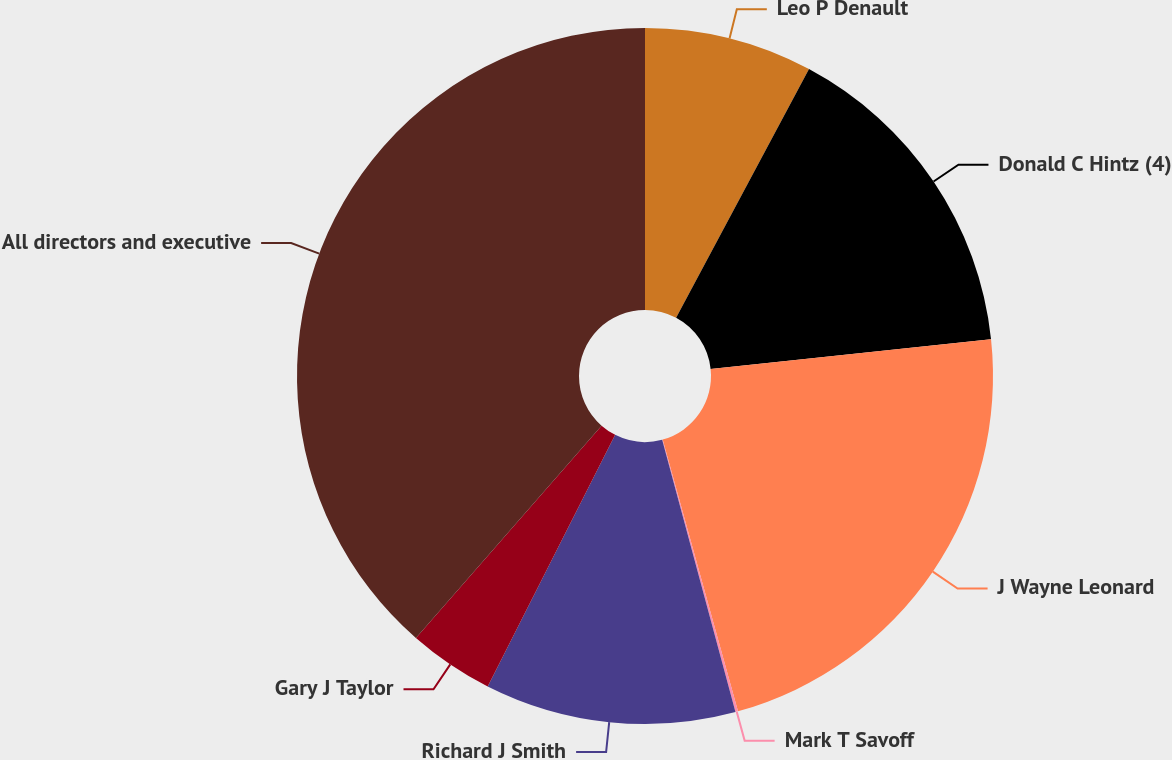Convert chart to OTSL. <chart><loc_0><loc_0><loc_500><loc_500><pie_chart><fcel>Leo P Denault<fcel>Donald C Hintz (4)<fcel>J Wayne Leonard<fcel>Mark T Savoff<fcel>Richard J Smith<fcel>Gary J Taylor<fcel>All directors and executive<nl><fcel>7.81%<fcel>15.5%<fcel>22.38%<fcel>0.12%<fcel>11.65%<fcel>3.97%<fcel>38.56%<nl></chart> 